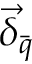<formula> <loc_0><loc_0><loc_500><loc_500>\vec { \delta } _ { \bar { q } }</formula> 